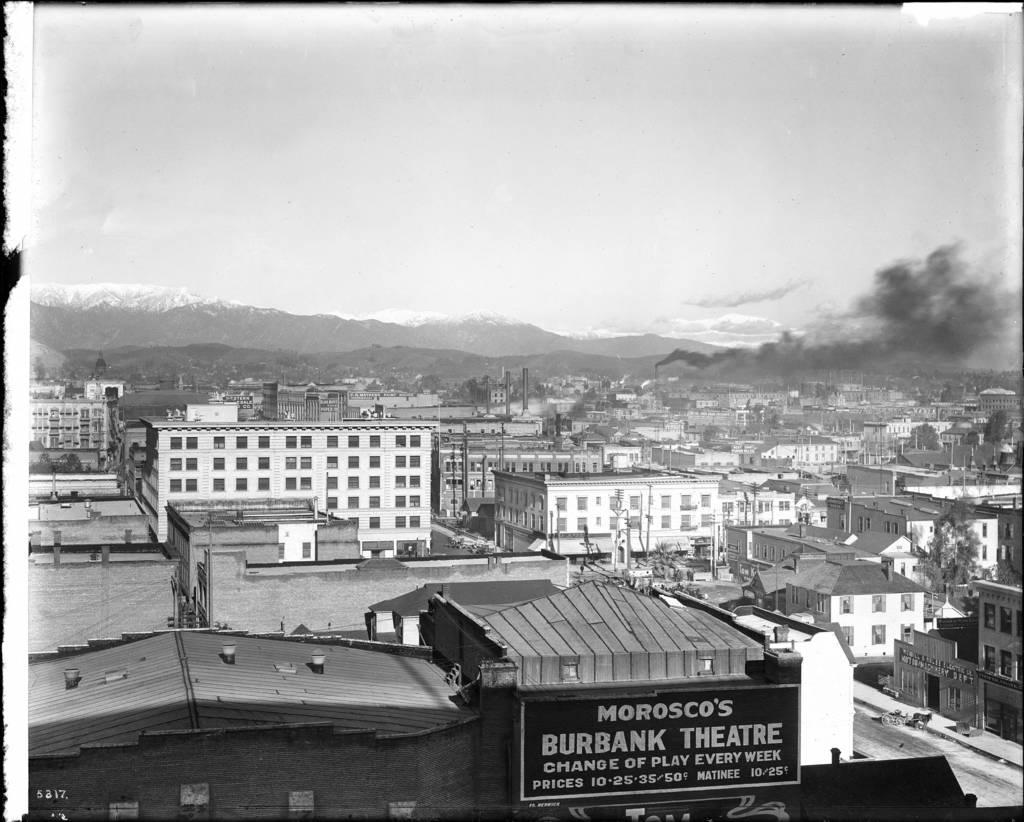<image>
Relay a brief, clear account of the picture shown. A black and white picture showing Morosco's Burbank Theatre at the bottom right corner. 